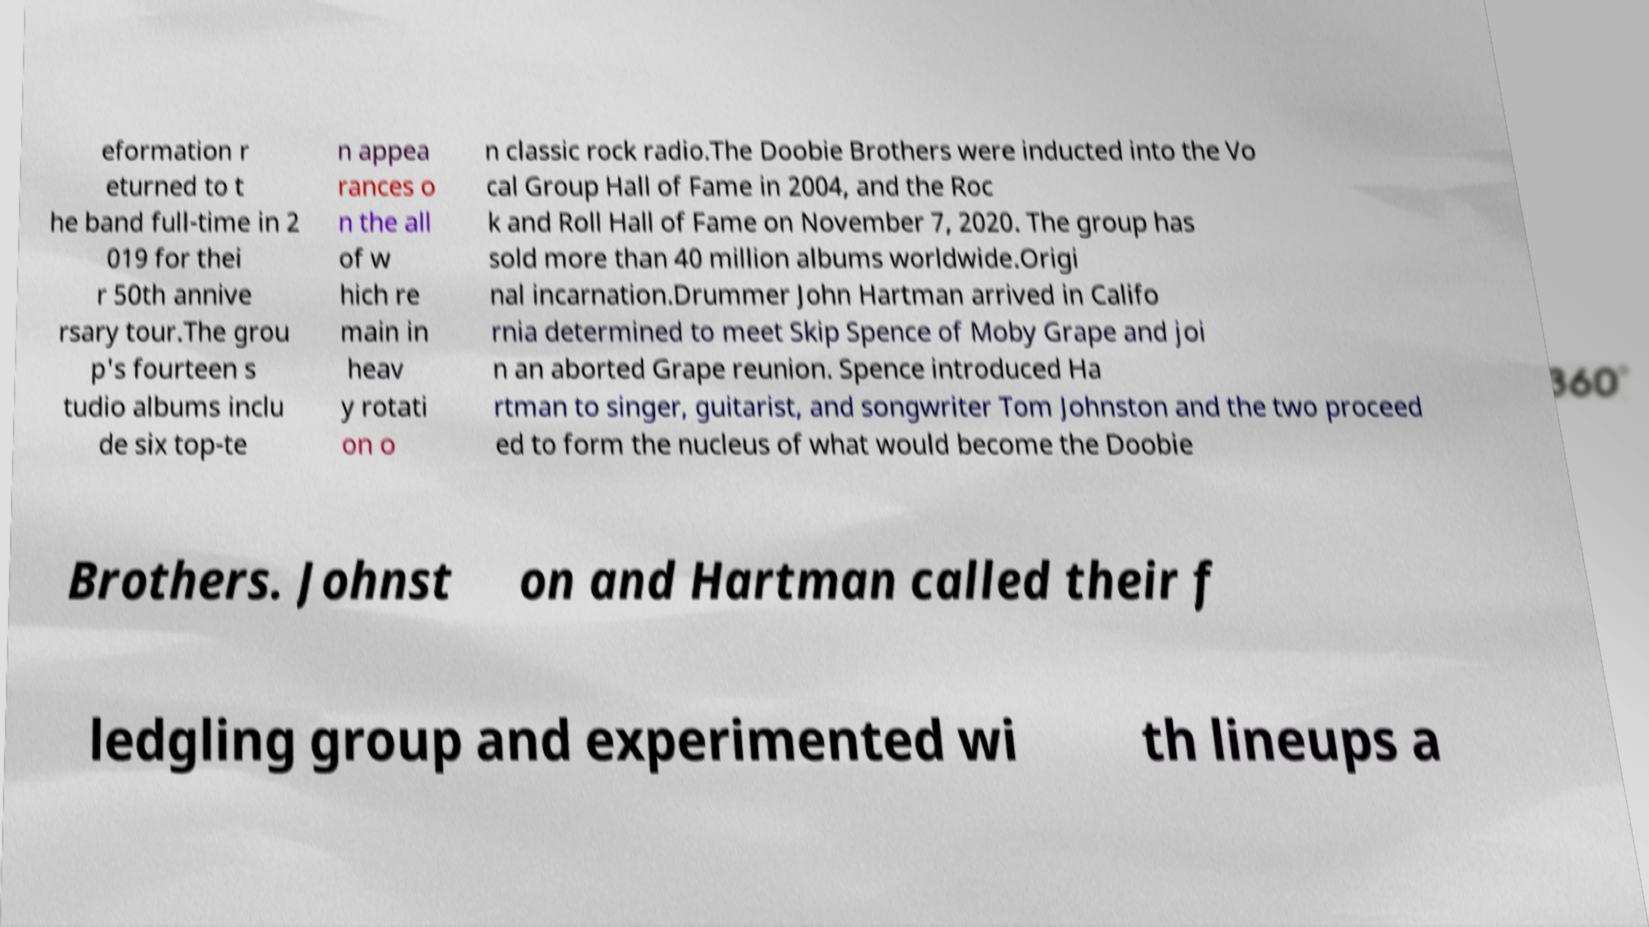I need the written content from this picture converted into text. Can you do that? eformation r eturned to t he band full-time in 2 019 for thei r 50th annive rsary tour.The grou p's fourteen s tudio albums inclu de six top-te n appea rances o n the all of w hich re main in heav y rotati on o n classic rock radio.The Doobie Brothers were inducted into the Vo cal Group Hall of Fame in 2004, and the Roc k and Roll Hall of Fame on November 7, 2020. The group has sold more than 40 million albums worldwide.Origi nal incarnation.Drummer John Hartman arrived in Califo rnia determined to meet Skip Spence of Moby Grape and joi n an aborted Grape reunion. Spence introduced Ha rtman to singer, guitarist, and songwriter Tom Johnston and the two proceed ed to form the nucleus of what would become the Doobie Brothers. Johnst on and Hartman called their f ledgling group and experimented wi th lineups a 